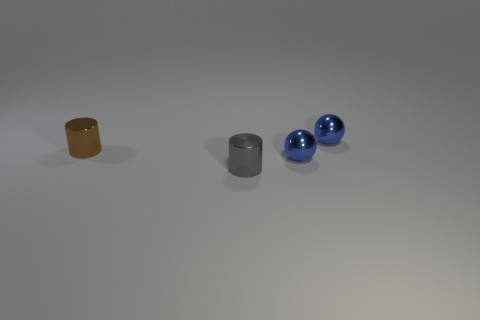How many blue balls must be subtracted to get 1 blue balls? 1 Add 3 big brown balls. How many objects exist? 7 Subtract 0 blue cylinders. How many objects are left? 4 Subtract 1 cylinders. How many cylinders are left? 1 Subtract all cyan spheres. Subtract all gray blocks. How many spheres are left? 2 Subtract all blue cylinders. How many purple balls are left? 0 Subtract all cylinders. Subtract all large brown rubber blocks. How many objects are left? 2 Add 1 gray things. How many gray things are left? 2 Add 4 tiny blue metallic spheres. How many tiny blue metallic spheres exist? 6 Subtract all gray cylinders. How many cylinders are left? 1 